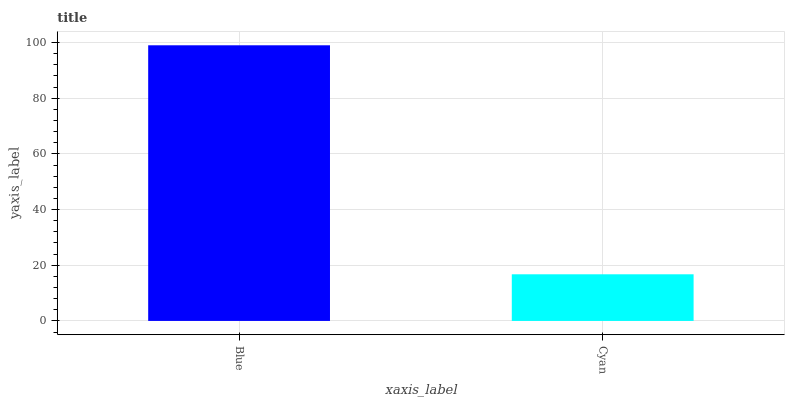Is Cyan the minimum?
Answer yes or no. Yes. Is Blue the maximum?
Answer yes or no. Yes. Is Cyan the maximum?
Answer yes or no. No. Is Blue greater than Cyan?
Answer yes or no. Yes. Is Cyan less than Blue?
Answer yes or no. Yes. Is Cyan greater than Blue?
Answer yes or no. No. Is Blue less than Cyan?
Answer yes or no. No. Is Blue the high median?
Answer yes or no. Yes. Is Cyan the low median?
Answer yes or no. Yes. Is Cyan the high median?
Answer yes or no. No. Is Blue the low median?
Answer yes or no. No. 